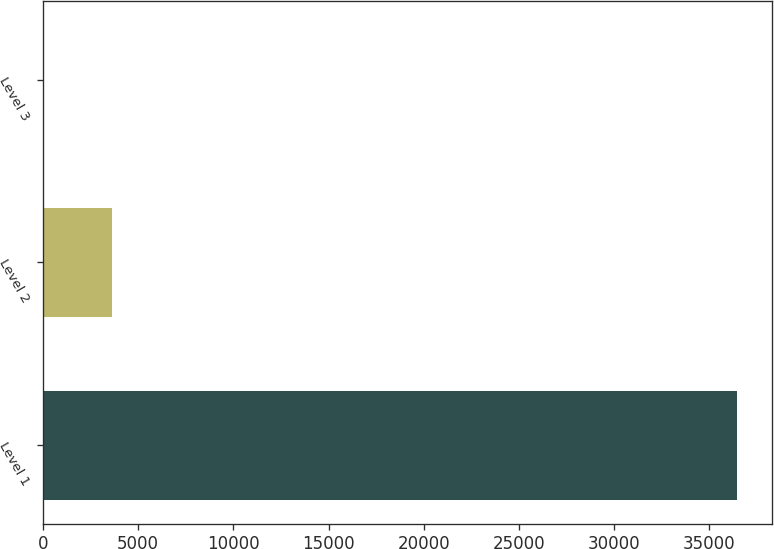Convert chart to OTSL. <chart><loc_0><loc_0><loc_500><loc_500><bar_chart><fcel>Level 1<fcel>Level 2<fcel>Level 3<nl><fcel>36468<fcel>3647.8<fcel>1.11<nl></chart> 